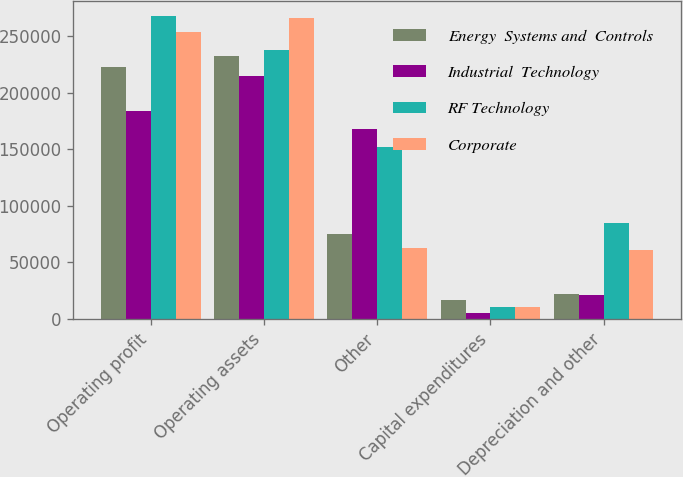Convert chart to OTSL. <chart><loc_0><loc_0><loc_500><loc_500><stacked_bar_chart><ecel><fcel>Operating profit<fcel>Operating assets<fcel>Other<fcel>Capital expenditures<fcel>Depreciation and other<nl><fcel>Energy  Systems and  Controls<fcel>223053<fcel>232505<fcel>75215<fcel>17043<fcel>21551<nl><fcel>Industrial  Technology<fcel>183679<fcel>214926<fcel>167879<fcel>4952<fcel>21353<nl><fcel>RF Technology<fcel>268172<fcel>237681<fcel>152211<fcel>10231<fcel>85177<nl><fcel>Corporate<fcel>253532<fcel>266026<fcel>62576<fcel>10190<fcel>60590<nl></chart> 